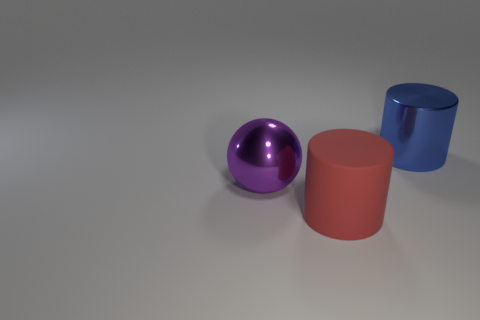What is the big thing that is both in front of the big blue cylinder and behind the matte cylinder made of?
Offer a terse response. Metal. How many balls are small green rubber things or big things?
Provide a short and direct response. 1. How many things are either red cylinders or big cylinders left of the big blue cylinder?
Keep it short and to the point. 1. Are any small spheres visible?
Keep it short and to the point. No. Is there a ball that has the same material as the large purple thing?
Your answer should be compact. No. There is a red thing that is the same size as the purple sphere; what material is it?
Your answer should be very brief. Rubber. There is a large cylinder that is on the left side of the large blue shiny thing; are there any blue cylinders that are behind it?
Keep it short and to the point. Yes. There is a object behind the big purple ball; is its shape the same as the object in front of the big purple object?
Offer a very short reply. Yes. Are the thing left of the big red cylinder and the cylinder on the left side of the large blue shiny object made of the same material?
Offer a terse response. No. What material is the big object on the left side of the thing in front of the large metallic ball?
Give a very brief answer. Metal. 